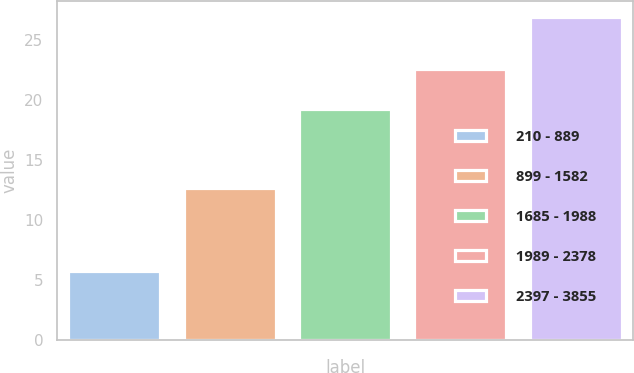Convert chart. <chart><loc_0><loc_0><loc_500><loc_500><bar_chart><fcel>210 - 889<fcel>899 - 1582<fcel>1685 - 1988<fcel>1989 - 2378<fcel>2397 - 3855<nl><fcel>5.74<fcel>12.65<fcel>19.22<fcel>22.53<fcel>26.89<nl></chart> 